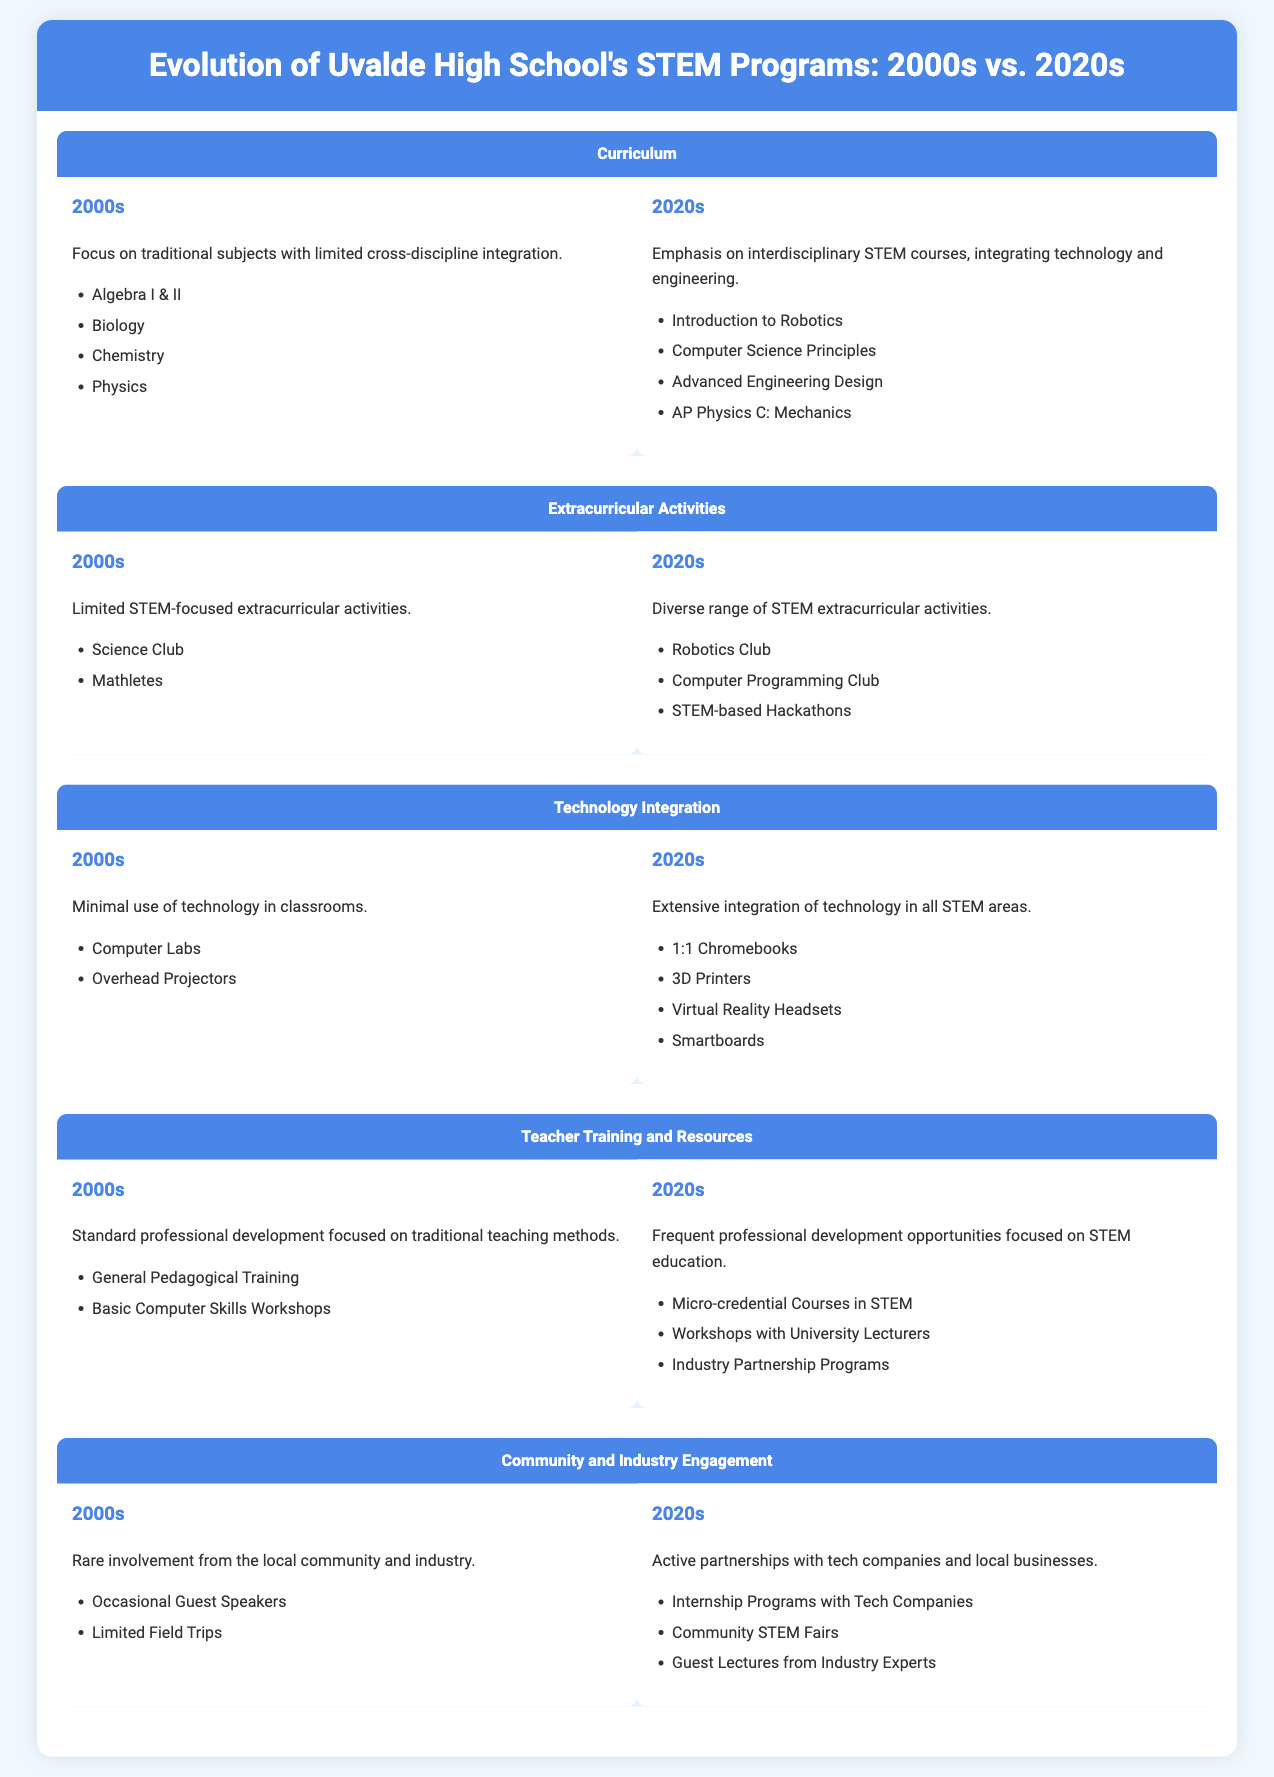What was the focus of the curriculum in the 2000s? The curriculum in the 2000s focused on traditional subjects with limited cross-discipline integration.
Answer: traditional subjects What advanced engineering course is offered in the 2020s? The infographic lists "Advanced Engineering Design" as an advanced engineering course offered in the 2020s.
Answer: Advanced Engineering Design What extracurricular activity was introduced in the 2020s? The "Robotics Club" is an extracurricular activity that was introduced in the 2020s.
Answer: Robotics Club How was technology used in classrooms during the 2000s? The document states there was minimal use of technology in classrooms during the 2000s.
Answer: minimal use What type of training did teachers receive in the 2020s? Teachers in the 2020s received frequent professional development opportunities focused on STEM education.
Answer: frequent professional development How many types of technology are listed for the 2020s? The 2020s technology section lists four types of technology integrated into classrooms.
Answer: four types What was the nature of community engagement in the 2000s? Community engagement in the 2000s was characterized by rare involvement from the local community and industry.
Answer: rare involvement What is a notable change in industry engagement from the 2000s to the 2020s? In the 2020s, there are active partnerships with tech companies and local businesses, while it was rare in the 2000s.
Answer: active partnerships 